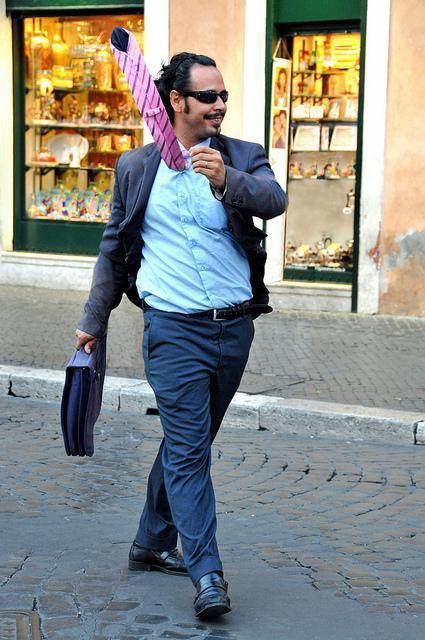What is this man experiencing?
From the following four choices, select the correct answer to address the question.
Options: Sleet, snow, rain, high wind. High wind. 